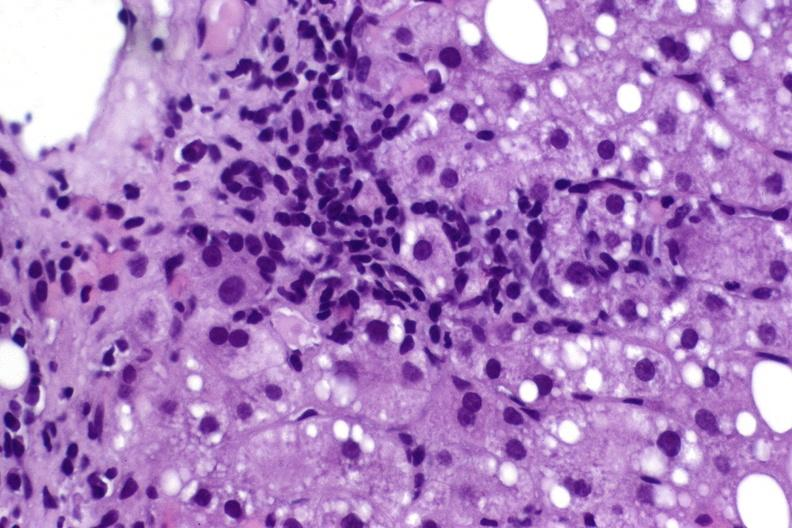what is present?
Answer the question using a single word or phrase. Liver 